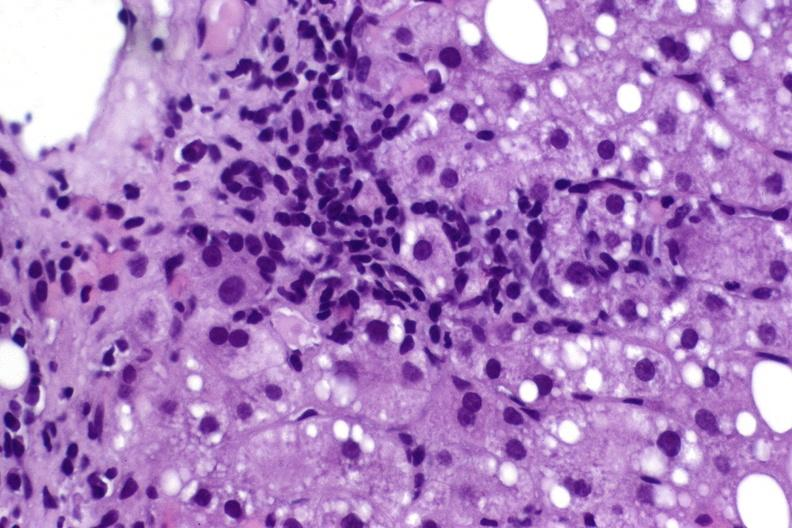what is present?
Answer the question using a single word or phrase. Liver 